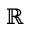<formula> <loc_0><loc_0><loc_500><loc_500>\mathbb { R }</formula> 